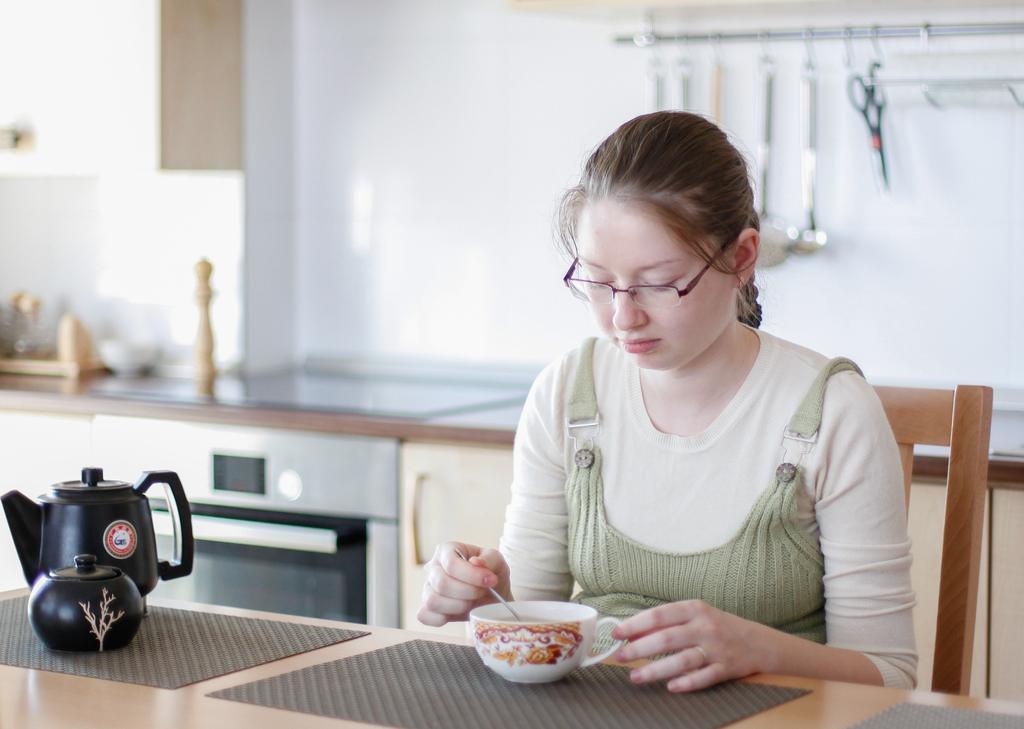In one or two sentences, can you explain what this image depicts? In this picture we can see a woman who is sitting on the chair. She has spectacles. This is table. On table there is a jar and a cup. On the background there is a wall. And these are the spoons. 